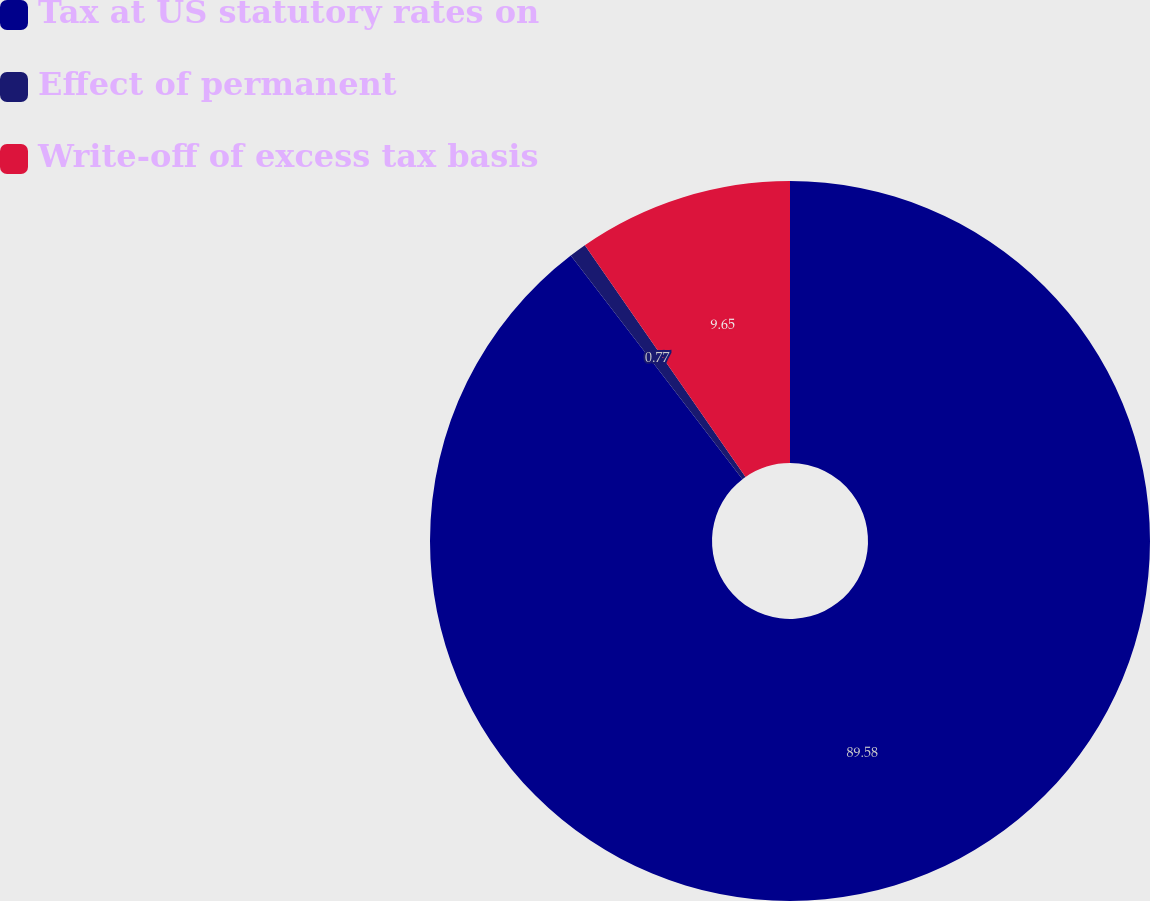<chart> <loc_0><loc_0><loc_500><loc_500><pie_chart><fcel>Tax at US statutory rates on<fcel>Effect of permanent<fcel>Write-off of excess tax basis<nl><fcel>89.58%<fcel>0.77%<fcel>9.65%<nl></chart> 